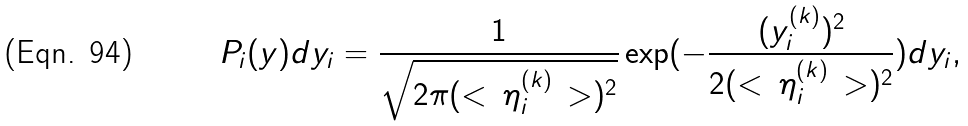Convert formula to latex. <formula><loc_0><loc_0><loc_500><loc_500>P _ { i } ( y ) d y _ { i } = \frac { 1 } { \sqrt { 2 \pi ( < \, \eta ^ { ( k ) } _ { i } \, > ) ^ { 2 } } } \exp ( - \frac { ( y ^ { ( k ) } _ { i } ) ^ { 2 } } { 2 ( < \, \eta ^ { ( k ) } _ { i } \, > ) ^ { 2 } } ) d y _ { i } ,</formula> 